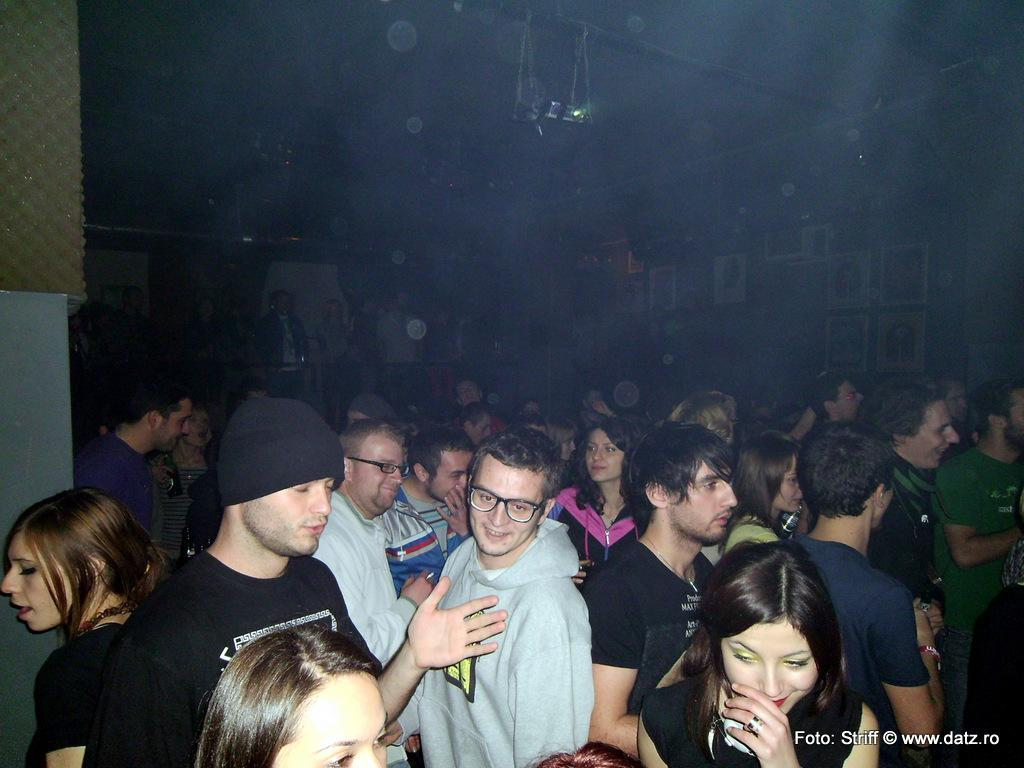How many people are in the image? There is a group of people in the image. What are some of the people doing in the image? Some of the people are smiling. Where are the photo frames located in the image? The photo frames are on the right side of the image. What type of pickle is being used as a game piece in the image? There is no pickle or game present in the image. How many people are missing from the image? The image does not indicate any missing people, as it shows a group of people. 